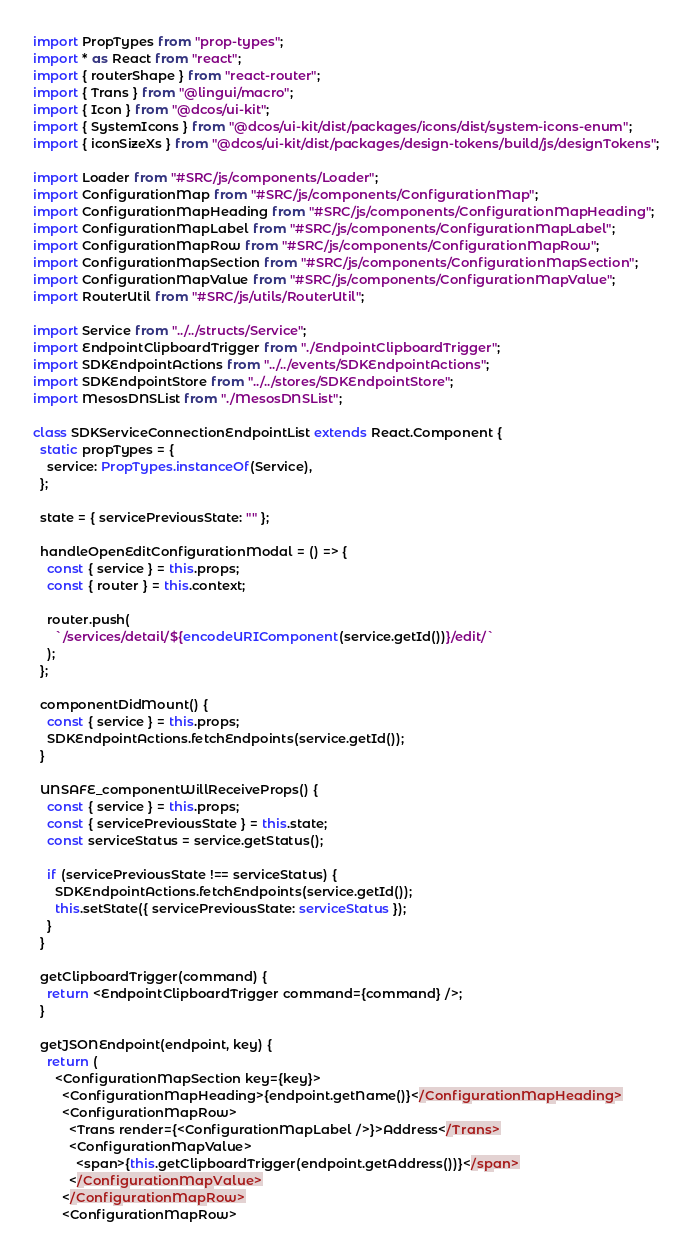Convert code to text. <code><loc_0><loc_0><loc_500><loc_500><_TypeScript_>import PropTypes from "prop-types";
import * as React from "react";
import { routerShape } from "react-router";
import { Trans } from "@lingui/macro";
import { Icon } from "@dcos/ui-kit";
import { SystemIcons } from "@dcos/ui-kit/dist/packages/icons/dist/system-icons-enum";
import { iconSizeXs } from "@dcos/ui-kit/dist/packages/design-tokens/build/js/designTokens";

import Loader from "#SRC/js/components/Loader";
import ConfigurationMap from "#SRC/js/components/ConfigurationMap";
import ConfigurationMapHeading from "#SRC/js/components/ConfigurationMapHeading";
import ConfigurationMapLabel from "#SRC/js/components/ConfigurationMapLabel";
import ConfigurationMapRow from "#SRC/js/components/ConfigurationMapRow";
import ConfigurationMapSection from "#SRC/js/components/ConfigurationMapSection";
import ConfigurationMapValue from "#SRC/js/components/ConfigurationMapValue";
import RouterUtil from "#SRC/js/utils/RouterUtil";

import Service from "../../structs/Service";
import EndpointClipboardTrigger from "./EndpointClipboardTrigger";
import SDKEndpointActions from "../../events/SDKEndpointActions";
import SDKEndpointStore from "../../stores/SDKEndpointStore";
import MesosDNSList from "./MesosDNSList";

class SDKServiceConnectionEndpointList extends React.Component {
  static propTypes = {
    service: PropTypes.instanceOf(Service),
  };

  state = { servicePreviousState: "" };

  handleOpenEditConfigurationModal = () => {
    const { service } = this.props;
    const { router } = this.context;

    router.push(
      `/services/detail/${encodeURIComponent(service.getId())}/edit/`
    );
  };

  componentDidMount() {
    const { service } = this.props;
    SDKEndpointActions.fetchEndpoints(service.getId());
  }

  UNSAFE_componentWillReceiveProps() {
    const { service } = this.props;
    const { servicePreviousState } = this.state;
    const serviceStatus = service.getStatus();

    if (servicePreviousState !== serviceStatus) {
      SDKEndpointActions.fetchEndpoints(service.getId());
      this.setState({ servicePreviousState: serviceStatus });
    }
  }

  getClipboardTrigger(command) {
    return <EndpointClipboardTrigger command={command} />;
  }

  getJSONEndpoint(endpoint, key) {
    return (
      <ConfigurationMapSection key={key}>
        <ConfigurationMapHeading>{endpoint.getName()}</ConfigurationMapHeading>
        <ConfigurationMapRow>
          <Trans render={<ConfigurationMapLabel />}>Address</Trans>
          <ConfigurationMapValue>
            <span>{this.getClipboardTrigger(endpoint.getAddress())}</span>
          </ConfigurationMapValue>
        </ConfigurationMapRow>
        <ConfigurationMapRow></code> 